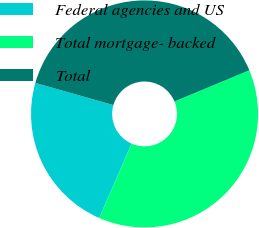Convert chart to OTSL. <chart><loc_0><loc_0><loc_500><loc_500><pie_chart><fcel>Federal agencies and US<fcel>Total mortgage- backed<fcel>Total<nl><fcel>22.85%<fcel>37.82%<fcel>39.32%<nl></chart> 